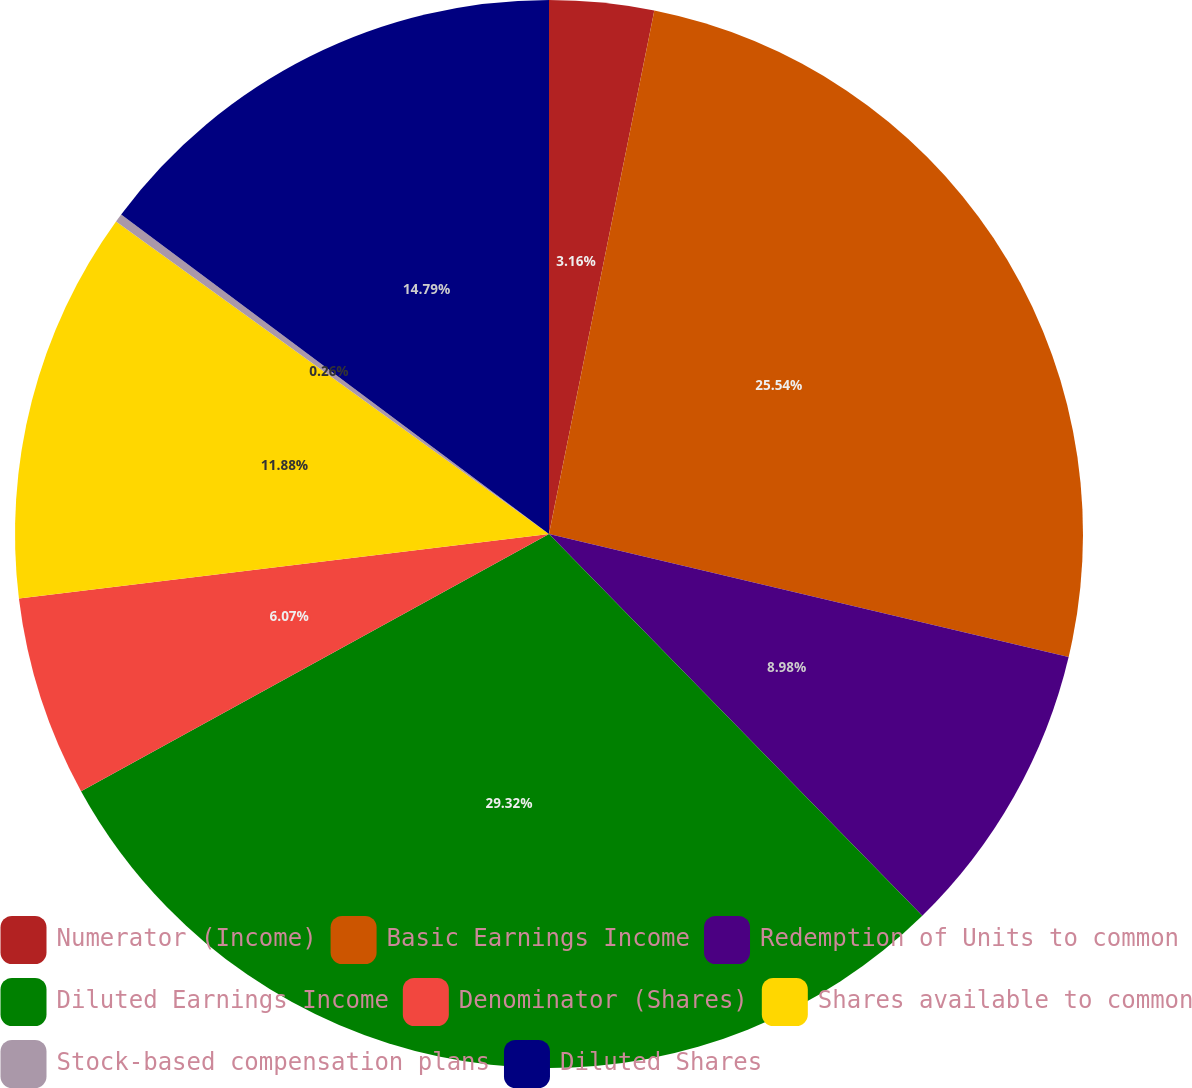Convert chart. <chart><loc_0><loc_0><loc_500><loc_500><pie_chart><fcel>Numerator (Income)<fcel>Basic Earnings Income<fcel>Redemption of Units to common<fcel>Diluted Earnings Income<fcel>Denominator (Shares)<fcel>Shares available to common<fcel>Stock-based compensation plans<fcel>Diluted Shares<nl><fcel>3.16%<fcel>25.54%<fcel>8.98%<fcel>29.32%<fcel>6.07%<fcel>11.88%<fcel>0.26%<fcel>14.79%<nl></chart> 